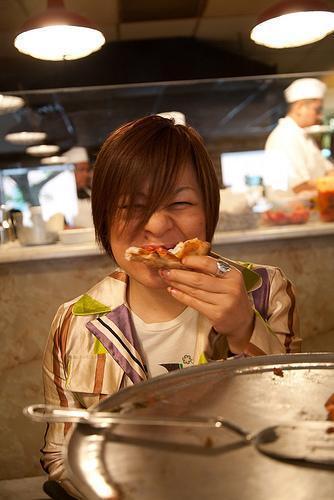How many people can you see?
Give a very brief answer. 2. 